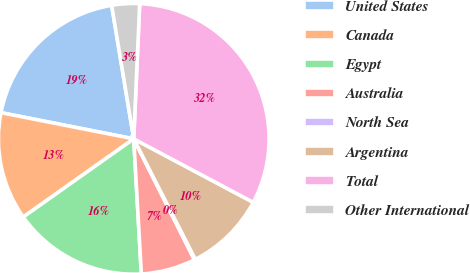Convert chart to OTSL. <chart><loc_0><loc_0><loc_500><loc_500><pie_chart><fcel>United States<fcel>Canada<fcel>Egypt<fcel>Australia<fcel>North Sea<fcel>Argentina<fcel>Total<fcel>Other International<nl><fcel>19.29%<fcel>12.9%<fcel>16.09%<fcel>6.51%<fcel>0.12%<fcel>9.7%<fcel>32.07%<fcel>3.31%<nl></chart> 